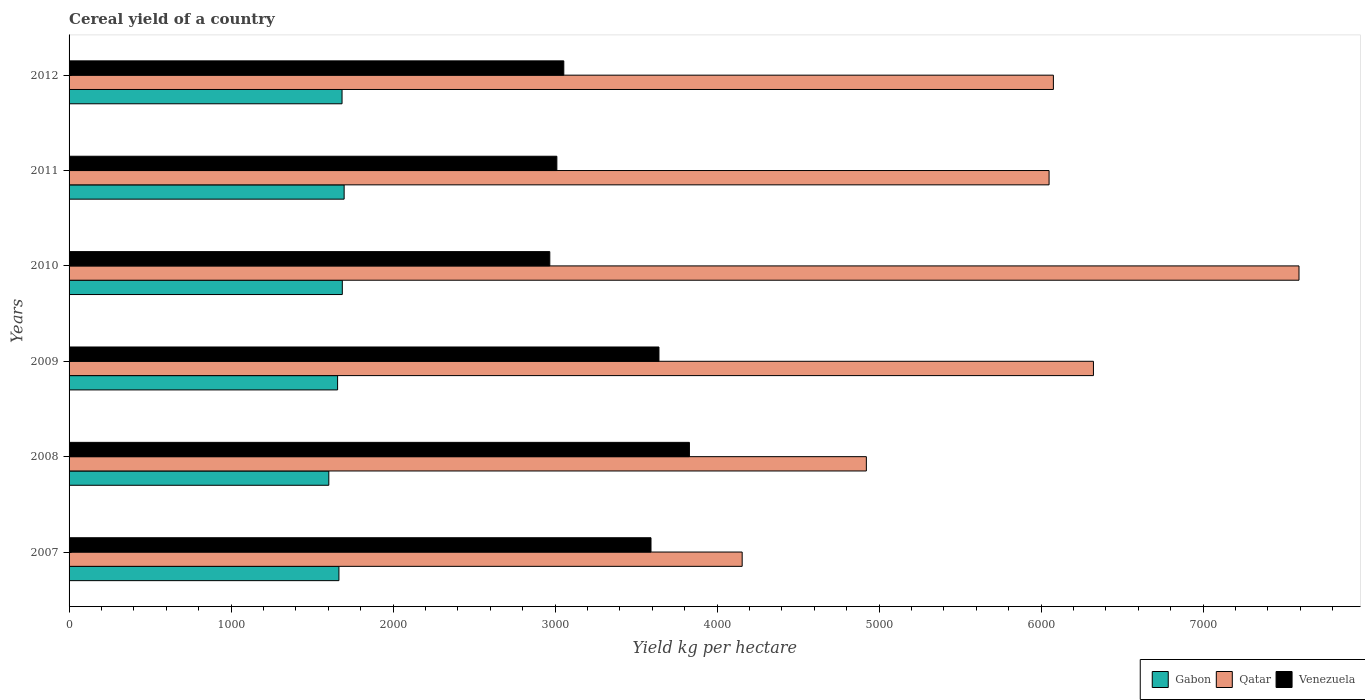How many different coloured bars are there?
Your answer should be very brief. 3. Are the number of bars per tick equal to the number of legend labels?
Offer a terse response. Yes. Are the number of bars on each tick of the Y-axis equal?
Keep it short and to the point. Yes. How many bars are there on the 1st tick from the top?
Keep it short and to the point. 3. How many bars are there on the 6th tick from the bottom?
Offer a very short reply. 3. What is the total cereal yield in Gabon in 2010?
Provide a short and direct response. 1686.77. Across all years, what is the maximum total cereal yield in Venezuela?
Offer a terse response. 3829.52. Across all years, what is the minimum total cereal yield in Qatar?
Ensure brevity in your answer.  4155.18. In which year was the total cereal yield in Gabon minimum?
Give a very brief answer. 2008. What is the total total cereal yield in Venezuela in the graph?
Make the answer very short. 2.01e+04. What is the difference between the total cereal yield in Qatar in 2008 and that in 2009?
Your response must be concise. -1401.77. What is the difference between the total cereal yield in Venezuela in 2011 and the total cereal yield in Qatar in 2012?
Your answer should be compact. -3065.24. What is the average total cereal yield in Qatar per year?
Your answer should be compact. 5853.26. In the year 2010, what is the difference between the total cereal yield in Gabon and total cereal yield in Qatar?
Ensure brevity in your answer.  -5905.82. In how many years, is the total cereal yield in Qatar greater than 4000 kg per hectare?
Provide a short and direct response. 6. What is the ratio of the total cereal yield in Qatar in 2007 to that in 2011?
Your response must be concise. 0.69. What is the difference between the highest and the second highest total cereal yield in Qatar?
Your answer should be very brief. 1268.95. What is the difference between the highest and the lowest total cereal yield in Gabon?
Provide a short and direct response. 94.57. In how many years, is the total cereal yield in Gabon greater than the average total cereal yield in Gabon taken over all years?
Make the answer very short. 3. Is the sum of the total cereal yield in Gabon in 2009 and 2010 greater than the maximum total cereal yield in Venezuela across all years?
Your answer should be very brief. No. What does the 3rd bar from the top in 2008 represents?
Keep it short and to the point. Gabon. What does the 1st bar from the bottom in 2008 represents?
Provide a short and direct response. Gabon. How many bars are there?
Ensure brevity in your answer.  18. Are all the bars in the graph horizontal?
Provide a short and direct response. Yes. How many years are there in the graph?
Your answer should be compact. 6. Are the values on the major ticks of X-axis written in scientific E-notation?
Your answer should be very brief. No. Does the graph contain any zero values?
Offer a very short reply. No. Does the graph contain grids?
Give a very brief answer. No. Where does the legend appear in the graph?
Your answer should be compact. Bottom right. What is the title of the graph?
Offer a terse response. Cereal yield of a country. Does "Nicaragua" appear as one of the legend labels in the graph?
Your answer should be compact. No. What is the label or title of the X-axis?
Ensure brevity in your answer.  Yield kg per hectare. What is the label or title of the Y-axis?
Keep it short and to the point. Years. What is the Yield kg per hectare of Gabon in 2007?
Ensure brevity in your answer.  1665.85. What is the Yield kg per hectare of Qatar in 2007?
Your response must be concise. 4155.18. What is the Yield kg per hectare in Venezuela in 2007?
Offer a terse response. 3592.41. What is the Yield kg per hectare in Gabon in 2008?
Your response must be concise. 1603.45. What is the Yield kg per hectare of Qatar in 2008?
Provide a short and direct response. 4921.88. What is the Yield kg per hectare in Venezuela in 2008?
Offer a very short reply. 3829.52. What is the Yield kg per hectare in Gabon in 2009?
Provide a succinct answer. 1657.62. What is the Yield kg per hectare of Qatar in 2009?
Provide a succinct answer. 6323.65. What is the Yield kg per hectare of Venezuela in 2009?
Your response must be concise. 3641.5. What is the Yield kg per hectare in Gabon in 2010?
Provide a short and direct response. 1686.77. What is the Yield kg per hectare of Qatar in 2010?
Keep it short and to the point. 7592.59. What is the Yield kg per hectare in Venezuela in 2010?
Give a very brief answer. 2967.64. What is the Yield kg per hectare of Gabon in 2011?
Your response must be concise. 1698.02. What is the Yield kg per hectare of Qatar in 2011?
Give a very brief answer. 6049.82. What is the Yield kg per hectare of Venezuela in 2011?
Your answer should be compact. 3011.19. What is the Yield kg per hectare in Gabon in 2012?
Ensure brevity in your answer.  1685.1. What is the Yield kg per hectare in Qatar in 2012?
Your answer should be compact. 6076.43. What is the Yield kg per hectare in Venezuela in 2012?
Make the answer very short. 3054.08. Across all years, what is the maximum Yield kg per hectare of Gabon?
Offer a terse response. 1698.02. Across all years, what is the maximum Yield kg per hectare in Qatar?
Your response must be concise. 7592.59. Across all years, what is the maximum Yield kg per hectare in Venezuela?
Give a very brief answer. 3829.52. Across all years, what is the minimum Yield kg per hectare of Gabon?
Provide a short and direct response. 1603.45. Across all years, what is the minimum Yield kg per hectare in Qatar?
Make the answer very short. 4155.18. Across all years, what is the minimum Yield kg per hectare in Venezuela?
Provide a short and direct response. 2967.64. What is the total Yield kg per hectare of Gabon in the graph?
Your answer should be very brief. 9996.82. What is the total Yield kg per hectare in Qatar in the graph?
Provide a short and direct response. 3.51e+04. What is the total Yield kg per hectare in Venezuela in the graph?
Your answer should be compact. 2.01e+04. What is the difference between the Yield kg per hectare of Gabon in 2007 and that in 2008?
Make the answer very short. 62.4. What is the difference between the Yield kg per hectare in Qatar in 2007 and that in 2008?
Provide a short and direct response. -766.7. What is the difference between the Yield kg per hectare of Venezuela in 2007 and that in 2008?
Keep it short and to the point. -237.11. What is the difference between the Yield kg per hectare of Gabon in 2007 and that in 2009?
Offer a terse response. 8.23. What is the difference between the Yield kg per hectare of Qatar in 2007 and that in 2009?
Ensure brevity in your answer.  -2168.47. What is the difference between the Yield kg per hectare in Venezuela in 2007 and that in 2009?
Provide a succinct answer. -49.09. What is the difference between the Yield kg per hectare of Gabon in 2007 and that in 2010?
Make the answer very short. -20.92. What is the difference between the Yield kg per hectare of Qatar in 2007 and that in 2010?
Offer a very short reply. -3437.42. What is the difference between the Yield kg per hectare of Venezuela in 2007 and that in 2010?
Your answer should be compact. 624.77. What is the difference between the Yield kg per hectare in Gabon in 2007 and that in 2011?
Provide a succinct answer. -32.17. What is the difference between the Yield kg per hectare in Qatar in 2007 and that in 2011?
Your response must be concise. -1894.65. What is the difference between the Yield kg per hectare in Venezuela in 2007 and that in 2011?
Ensure brevity in your answer.  581.22. What is the difference between the Yield kg per hectare in Gabon in 2007 and that in 2012?
Keep it short and to the point. -19.25. What is the difference between the Yield kg per hectare in Qatar in 2007 and that in 2012?
Your response must be concise. -1921.26. What is the difference between the Yield kg per hectare in Venezuela in 2007 and that in 2012?
Your answer should be very brief. 538.33. What is the difference between the Yield kg per hectare of Gabon in 2008 and that in 2009?
Offer a terse response. -54.17. What is the difference between the Yield kg per hectare in Qatar in 2008 and that in 2009?
Give a very brief answer. -1401.77. What is the difference between the Yield kg per hectare in Venezuela in 2008 and that in 2009?
Your response must be concise. 188.02. What is the difference between the Yield kg per hectare in Gabon in 2008 and that in 2010?
Offer a terse response. -83.32. What is the difference between the Yield kg per hectare of Qatar in 2008 and that in 2010?
Provide a short and direct response. -2670.72. What is the difference between the Yield kg per hectare in Venezuela in 2008 and that in 2010?
Offer a very short reply. 861.88. What is the difference between the Yield kg per hectare in Gabon in 2008 and that in 2011?
Your response must be concise. -94.57. What is the difference between the Yield kg per hectare in Qatar in 2008 and that in 2011?
Your answer should be very brief. -1127.95. What is the difference between the Yield kg per hectare in Venezuela in 2008 and that in 2011?
Make the answer very short. 818.33. What is the difference between the Yield kg per hectare of Gabon in 2008 and that in 2012?
Your answer should be compact. -81.66. What is the difference between the Yield kg per hectare in Qatar in 2008 and that in 2012?
Your answer should be compact. -1154.56. What is the difference between the Yield kg per hectare of Venezuela in 2008 and that in 2012?
Keep it short and to the point. 775.44. What is the difference between the Yield kg per hectare in Gabon in 2009 and that in 2010?
Offer a terse response. -29.15. What is the difference between the Yield kg per hectare in Qatar in 2009 and that in 2010?
Keep it short and to the point. -1268.95. What is the difference between the Yield kg per hectare of Venezuela in 2009 and that in 2010?
Your response must be concise. 673.85. What is the difference between the Yield kg per hectare of Gabon in 2009 and that in 2011?
Offer a very short reply. -40.4. What is the difference between the Yield kg per hectare of Qatar in 2009 and that in 2011?
Ensure brevity in your answer.  273.82. What is the difference between the Yield kg per hectare in Venezuela in 2009 and that in 2011?
Offer a terse response. 630.3. What is the difference between the Yield kg per hectare in Gabon in 2009 and that in 2012?
Make the answer very short. -27.48. What is the difference between the Yield kg per hectare in Qatar in 2009 and that in 2012?
Make the answer very short. 247.21. What is the difference between the Yield kg per hectare of Venezuela in 2009 and that in 2012?
Offer a very short reply. 587.42. What is the difference between the Yield kg per hectare of Gabon in 2010 and that in 2011?
Provide a succinct answer. -11.25. What is the difference between the Yield kg per hectare in Qatar in 2010 and that in 2011?
Your response must be concise. 1542.77. What is the difference between the Yield kg per hectare in Venezuela in 2010 and that in 2011?
Your answer should be compact. -43.55. What is the difference between the Yield kg per hectare in Gabon in 2010 and that in 2012?
Keep it short and to the point. 1.67. What is the difference between the Yield kg per hectare of Qatar in 2010 and that in 2012?
Offer a terse response. 1516.16. What is the difference between the Yield kg per hectare in Venezuela in 2010 and that in 2012?
Make the answer very short. -86.44. What is the difference between the Yield kg per hectare in Gabon in 2011 and that in 2012?
Give a very brief answer. 12.92. What is the difference between the Yield kg per hectare in Qatar in 2011 and that in 2012?
Your answer should be compact. -26.61. What is the difference between the Yield kg per hectare of Venezuela in 2011 and that in 2012?
Your answer should be compact. -42.88. What is the difference between the Yield kg per hectare of Gabon in 2007 and the Yield kg per hectare of Qatar in 2008?
Your answer should be compact. -3256.02. What is the difference between the Yield kg per hectare in Gabon in 2007 and the Yield kg per hectare in Venezuela in 2008?
Your answer should be very brief. -2163.67. What is the difference between the Yield kg per hectare in Qatar in 2007 and the Yield kg per hectare in Venezuela in 2008?
Your response must be concise. 325.65. What is the difference between the Yield kg per hectare in Gabon in 2007 and the Yield kg per hectare in Qatar in 2009?
Your response must be concise. -4657.8. What is the difference between the Yield kg per hectare in Gabon in 2007 and the Yield kg per hectare in Venezuela in 2009?
Keep it short and to the point. -1975.64. What is the difference between the Yield kg per hectare in Qatar in 2007 and the Yield kg per hectare in Venezuela in 2009?
Make the answer very short. 513.68. What is the difference between the Yield kg per hectare in Gabon in 2007 and the Yield kg per hectare in Qatar in 2010?
Ensure brevity in your answer.  -5926.74. What is the difference between the Yield kg per hectare of Gabon in 2007 and the Yield kg per hectare of Venezuela in 2010?
Your response must be concise. -1301.79. What is the difference between the Yield kg per hectare in Qatar in 2007 and the Yield kg per hectare in Venezuela in 2010?
Provide a short and direct response. 1187.53. What is the difference between the Yield kg per hectare in Gabon in 2007 and the Yield kg per hectare in Qatar in 2011?
Your answer should be compact. -4383.97. What is the difference between the Yield kg per hectare of Gabon in 2007 and the Yield kg per hectare of Venezuela in 2011?
Give a very brief answer. -1345.34. What is the difference between the Yield kg per hectare in Qatar in 2007 and the Yield kg per hectare in Venezuela in 2011?
Offer a terse response. 1143.98. What is the difference between the Yield kg per hectare of Gabon in 2007 and the Yield kg per hectare of Qatar in 2012?
Offer a terse response. -4410.58. What is the difference between the Yield kg per hectare in Gabon in 2007 and the Yield kg per hectare in Venezuela in 2012?
Offer a terse response. -1388.23. What is the difference between the Yield kg per hectare of Qatar in 2007 and the Yield kg per hectare of Venezuela in 2012?
Your response must be concise. 1101.1. What is the difference between the Yield kg per hectare in Gabon in 2008 and the Yield kg per hectare in Qatar in 2009?
Give a very brief answer. -4720.2. What is the difference between the Yield kg per hectare of Gabon in 2008 and the Yield kg per hectare of Venezuela in 2009?
Ensure brevity in your answer.  -2038.05. What is the difference between the Yield kg per hectare of Qatar in 2008 and the Yield kg per hectare of Venezuela in 2009?
Provide a short and direct response. 1280.38. What is the difference between the Yield kg per hectare of Gabon in 2008 and the Yield kg per hectare of Qatar in 2010?
Make the answer very short. -5989.15. What is the difference between the Yield kg per hectare of Gabon in 2008 and the Yield kg per hectare of Venezuela in 2010?
Make the answer very short. -1364.19. What is the difference between the Yield kg per hectare of Qatar in 2008 and the Yield kg per hectare of Venezuela in 2010?
Keep it short and to the point. 1954.23. What is the difference between the Yield kg per hectare in Gabon in 2008 and the Yield kg per hectare in Qatar in 2011?
Your answer should be very brief. -4446.37. What is the difference between the Yield kg per hectare of Gabon in 2008 and the Yield kg per hectare of Venezuela in 2011?
Provide a short and direct response. -1407.75. What is the difference between the Yield kg per hectare of Qatar in 2008 and the Yield kg per hectare of Venezuela in 2011?
Keep it short and to the point. 1910.68. What is the difference between the Yield kg per hectare of Gabon in 2008 and the Yield kg per hectare of Qatar in 2012?
Offer a terse response. -4472.98. What is the difference between the Yield kg per hectare of Gabon in 2008 and the Yield kg per hectare of Venezuela in 2012?
Keep it short and to the point. -1450.63. What is the difference between the Yield kg per hectare of Qatar in 2008 and the Yield kg per hectare of Venezuela in 2012?
Your answer should be very brief. 1867.8. What is the difference between the Yield kg per hectare in Gabon in 2009 and the Yield kg per hectare in Qatar in 2010?
Make the answer very short. -5934.97. What is the difference between the Yield kg per hectare of Gabon in 2009 and the Yield kg per hectare of Venezuela in 2010?
Give a very brief answer. -1310.02. What is the difference between the Yield kg per hectare of Qatar in 2009 and the Yield kg per hectare of Venezuela in 2010?
Provide a short and direct response. 3356.01. What is the difference between the Yield kg per hectare in Gabon in 2009 and the Yield kg per hectare in Qatar in 2011?
Ensure brevity in your answer.  -4392.2. What is the difference between the Yield kg per hectare of Gabon in 2009 and the Yield kg per hectare of Venezuela in 2011?
Your answer should be compact. -1353.57. What is the difference between the Yield kg per hectare of Qatar in 2009 and the Yield kg per hectare of Venezuela in 2011?
Your response must be concise. 3312.45. What is the difference between the Yield kg per hectare of Gabon in 2009 and the Yield kg per hectare of Qatar in 2012?
Your response must be concise. -4418.81. What is the difference between the Yield kg per hectare in Gabon in 2009 and the Yield kg per hectare in Venezuela in 2012?
Offer a very short reply. -1396.46. What is the difference between the Yield kg per hectare in Qatar in 2009 and the Yield kg per hectare in Venezuela in 2012?
Give a very brief answer. 3269.57. What is the difference between the Yield kg per hectare in Gabon in 2010 and the Yield kg per hectare in Qatar in 2011?
Keep it short and to the point. -4363.05. What is the difference between the Yield kg per hectare of Gabon in 2010 and the Yield kg per hectare of Venezuela in 2011?
Make the answer very short. -1324.42. What is the difference between the Yield kg per hectare of Qatar in 2010 and the Yield kg per hectare of Venezuela in 2011?
Ensure brevity in your answer.  4581.4. What is the difference between the Yield kg per hectare in Gabon in 2010 and the Yield kg per hectare in Qatar in 2012?
Provide a short and direct response. -4389.66. What is the difference between the Yield kg per hectare in Gabon in 2010 and the Yield kg per hectare in Venezuela in 2012?
Make the answer very short. -1367.31. What is the difference between the Yield kg per hectare of Qatar in 2010 and the Yield kg per hectare of Venezuela in 2012?
Your answer should be very brief. 4538.51. What is the difference between the Yield kg per hectare in Gabon in 2011 and the Yield kg per hectare in Qatar in 2012?
Give a very brief answer. -4378.41. What is the difference between the Yield kg per hectare in Gabon in 2011 and the Yield kg per hectare in Venezuela in 2012?
Provide a succinct answer. -1356.06. What is the difference between the Yield kg per hectare in Qatar in 2011 and the Yield kg per hectare in Venezuela in 2012?
Ensure brevity in your answer.  2995.74. What is the average Yield kg per hectare of Gabon per year?
Your response must be concise. 1666.14. What is the average Yield kg per hectare of Qatar per year?
Your answer should be compact. 5853.26. What is the average Yield kg per hectare in Venezuela per year?
Provide a short and direct response. 3349.39. In the year 2007, what is the difference between the Yield kg per hectare in Gabon and Yield kg per hectare in Qatar?
Offer a terse response. -2489.32. In the year 2007, what is the difference between the Yield kg per hectare of Gabon and Yield kg per hectare of Venezuela?
Give a very brief answer. -1926.56. In the year 2007, what is the difference between the Yield kg per hectare of Qatar and Yield kg per hectare of Venezuela?
Offer a terse response. 562.76. In the year 2008, what is the difference between the Yield kg per hectare in Gabon and Yield kg per hectare in Qatar?
Your answer should be compact. -3318.43. In the year 2008, what is the difference between the Yield kg per hectare of Gabon and Yield kg per hectare of Venezuela?
Provide a succinct answer. -2226.07. In the year 2008, what is the difference between the Yield kg per hectare in Qatar and Yield kg per hectare in Venezuela?
Make the answer very short. 1092.36. In the year 2009, what is the difference between the Yield kg per hectare of Gabon and Yield kg per hectare of Qatar?
Your response must be concise. -4666.02. In the year 2009, what is the difference between the Yield kg per hectare in Gabon and Yield kg per hectare in Venezuela?
Provide a short and direct response. -1983.87. In the year 2009, what is the difference between the Yield kg per hectare of Qatar and Yield kg per hectare of Venezuela?
Offer a very short reply. 2682.15. In the year 2010, what is the difference between the Yield kg per hectare in Gabon and Yield kg per hectare in Qatar?
Provide a short and direct response. -5905.82. In the year 2010, what is the difference between the Yield kg per hectare in Gabon and Yield kg per hectare in Venezuela?
Offer a very short reply. -1280.87. In the year 2010, what is the difference between the Yield kg per hectare in Qatar and Yield kg per hectare in Venezuela?
Provide a short and direct response. 4624.95. In the year 2011, what is the difference between the Yield kg per hectare in Gabon and Yield kg per hectare in Qatar?
Provide a succinct answer. -4351.8. In the year 2011, what is the difference between the Yield kg per hectare of Gabon and Yield kg per hectare of Venezuela?
Offer a terse response. -1313.17. In the year 2011, what is the difference between the Yield kg per hectare of Qatar and Yield kg per hectare of Venezuela?
Offer a very short reply. 3038.63. In the year 2012, what is the difference between the Yield kg per hectare in Gabon and Yield kg per hectare in Qatar?
Keep it short and to the point. -4391.33. In the year 2012, what is the difference between the Yield kg per hectare in Gabon and Yield kg per hectare in Venezuela?
Your response must be concise. -1368.98. In the year 2012, what is the difference between the Yield kg per hectare of Qatar and Yield kg per hectare of Venezuela?
Provide a succinct answer. 3022.35. What is the ratio of the Yield kg per hectare of Gabon in 2007 to that in 2008?
Ensure brevity in your answer.  1.04. What is the ratio of the Yield kg per hectare of Qatar in 2007 to that in 2008?
Your answer should be compact. 0.84. What is the ratio of the Yield kg per hectare in Venezuela in 2007 to that in 2008?
Your response must be concise. 0.94. What is the ratio of the Yield kg per hectare in Gabon in 2007 to that in 2009?
Your response must be concise. 1. What is the ratio of the Yield kg per hectare of Qatar in 2007 to that in 2009?
Offer a very short reply. 0.66. What is the ratio of the Yield kg per hectare of Venezuela in 2007 to that in 2009?
Provide a succinct answer. 0.99. What is the ratio of the Yield kg per hectare of Gabon in 2007 to that in 2010?
Your response must be concise. 0.99. What is the ratio of the Yield kg per hectare in Qatar in 2007 to that in 2010?
Your answer should be very brief. 0.55. What is the ratio of the Yield kg per hectare in Venezuela in 2007 to that in 2010?
Your answer should be compact. 1.21. What is the ratio of the Yield kg per hectare of Gabon in 2007 to that in 2011?
Make the answer very short. 0.98. What is the ratio of the Yield kg per hectare of Qatar in 2007 to that in 2011?
Your answer should be very brief. 0.69. What is the ratio of the Yield kg per hectare of Venezuela in 2007 to that in 2011?
Provide a short and direct response. 1.19. What is the ratio of the Yield kg per hectare of Gabon in 2007 to that in 2012?
Provide a short and direct response. 0.99. What is the ratio of the Yield kg per hectare of Qatar in 2007 to that in 2012?
Your answer should be very brief. 0.68. What is the ratio of the Yield kg per hectare in Venezuela in 2007 to that in 2012?
Offer a very short reply. 1.18. What is the ratio of the Yield kg per hectare in Gabon in 2008 to that in 2009?
Your answer should be compact. 0.97. What is the ratio of the Yield kg per hectare in Qatar in 2008 to that in 2009?
Your answer should be very brief. 0.78. What is the ratio of the Yield kg per hectare of Venezuela in 2008 to that in 2009?
Provide a succinct answer. 1.05. What is the ratio of the Yield kg per hectare in Gabon in 2008 to that in 2010?
Provide a short and direct response. 0.95. What is the ratio of the Yield kg per hectare of Qatar in 2008 to that in 2010?
Keep it short and to the point. 0.65. What is the ratio of the Yield kg per hectare in Venezuela in 2008 to that in 2010?
Offer a very short reply. 1.29. What is the ratio of the Yield kg per hectare in Gabon in 2008 to that in 2011?
Your answer should be compact. 0.94. What is the ratio of the Yield kg per hectare of Qatar in 2008 to that in 2011?
Your answer should be very brief. 0.81. What is the ratio of the Yield kg per hectare of Venezuela in 2008 to that in 2011?
Provide a succinct answer. 1.27. What is the ratio of the Yield kg per hectare of Gabon in 2008 to that in 2012?
Provide a short and direct response. 0.95. What is the ratio of the Yield kg per hectare of Qatar in 2008 to that in 2012?
Offer a very short reply. 0.81. What is the ratio of the Yield kg per hectare of Venezuela in 2008 to that in 2012?
Make the answer very short. 1.25. What is the ratio of the Yield kg per hectare in Gabon in 2009 to that in 2010?
Offer a very short reply. 0.98. What is the ratio of the Yield kg per hectare of Qatar in 2009 to that in 2010?
Your answer should be compact. 0.83. What is the ratio of the Yield kg per hectare in Venezuela in 2009 to that in 2010?
Offer a very short reply. 1.23. What is the ratio of the Yield kg per hectare in Gabon in 2009 to that in 2011?
Your answer should be very brief. 0.98. What is the ratio of the Yield kg per hectare in Qatar in 2009 to that in 2011?
Provide a succinct answer. 1.05. What is the ratio of the Yield kg per hectare of Venezuela in 2009 to that in 2011?
Offer a terse response. 1.21. What is the ratio of the Yield kg per hectare of Gabon in 2009 to that in 2012?
Provide a short and direct response. 0.98. What is the ratio of the Yield kg per hectare in Qatar in 2009 to that in 2012?
Your answer should be very brief. 1.04. What is the ratio of the Yield kg per hectare in Venezuela in 2009 to that in 2012?
Your answer should be compact. 1.19. What is the ratio of the Yield kg per hectare of Qatar in 2010 to that in 2011?
Keep it short and to the point. 1.25. What is the ratio of the Yield kg per hectare of Venezuela in 2010 to that in 2011?
Keep it short and to the point. 0.99. What is the ratio of the Yield kg per hectare of Gabon in 2010 to that in 2012?
Provide a succinct answer. 1. What is the ratio of the Yield kg per hectare in Qatar in 2010 to that in 2012?
Your response must be concise. 1.25. What is the ratio of the Yield kg per hectare of Venezuela in 2010 to that in 2012?
Keep it short and to the point. 0.97. What is the ratio of the Yield kg per hectare in Gabon in 2011 to that in 2012?
Your response must be concise. 1.01. What is the difference between the highest and the second highest Yield kg per hectare in Gabon?
Your answer should be compact. 11.25. What is the difference between the highest and the second highest Yield kg per hectare in Qatar?
Your answer should be very brief. 1268.95. What is the difference between the highest and the second highest Yield kg per hectare in Venezuela?
Your answer should be compact. 188.02. What is the difference between the highest and the lowest Yield kg per hectare in Gabon?
Your response must be concise. 94.57. What is the difference between the highest and the lowest Yield kg per hectare of Qatar?
Your answer should be compact. 3437.42. What is the difference between the highest and the lowest Yield kg per hectare in Venezuela?
Provide a short and direct response. 861.88. 